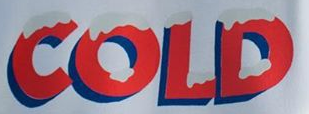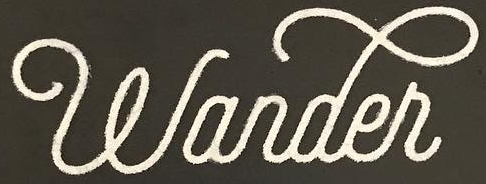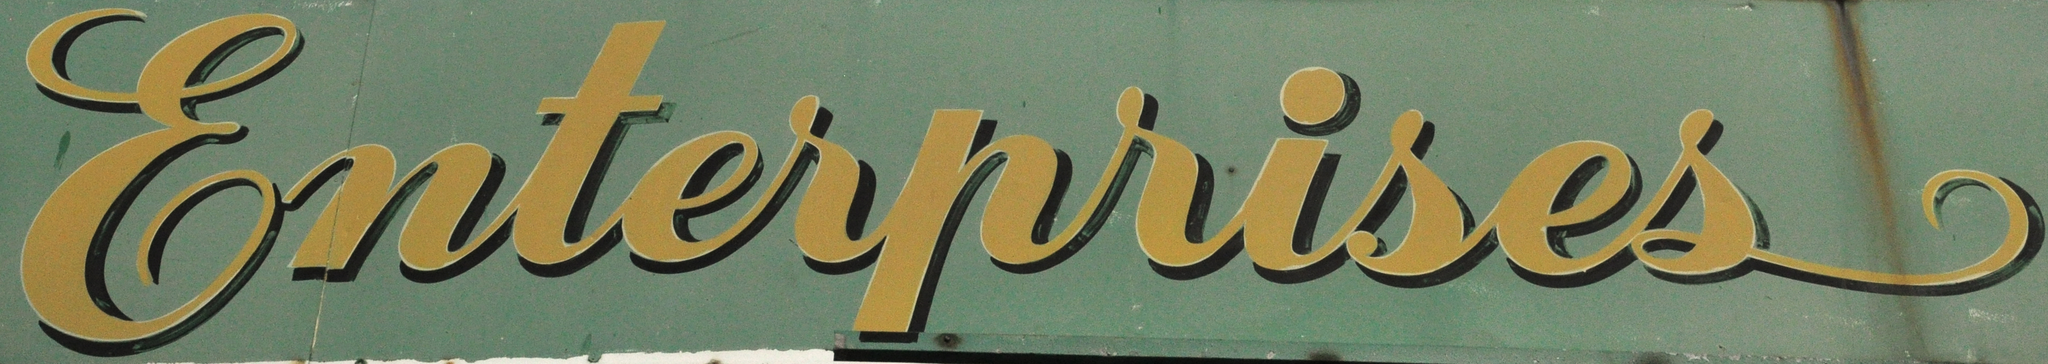Read the text from these images in sequence, separated by a semicolon. COLD; wander; Enterprises 